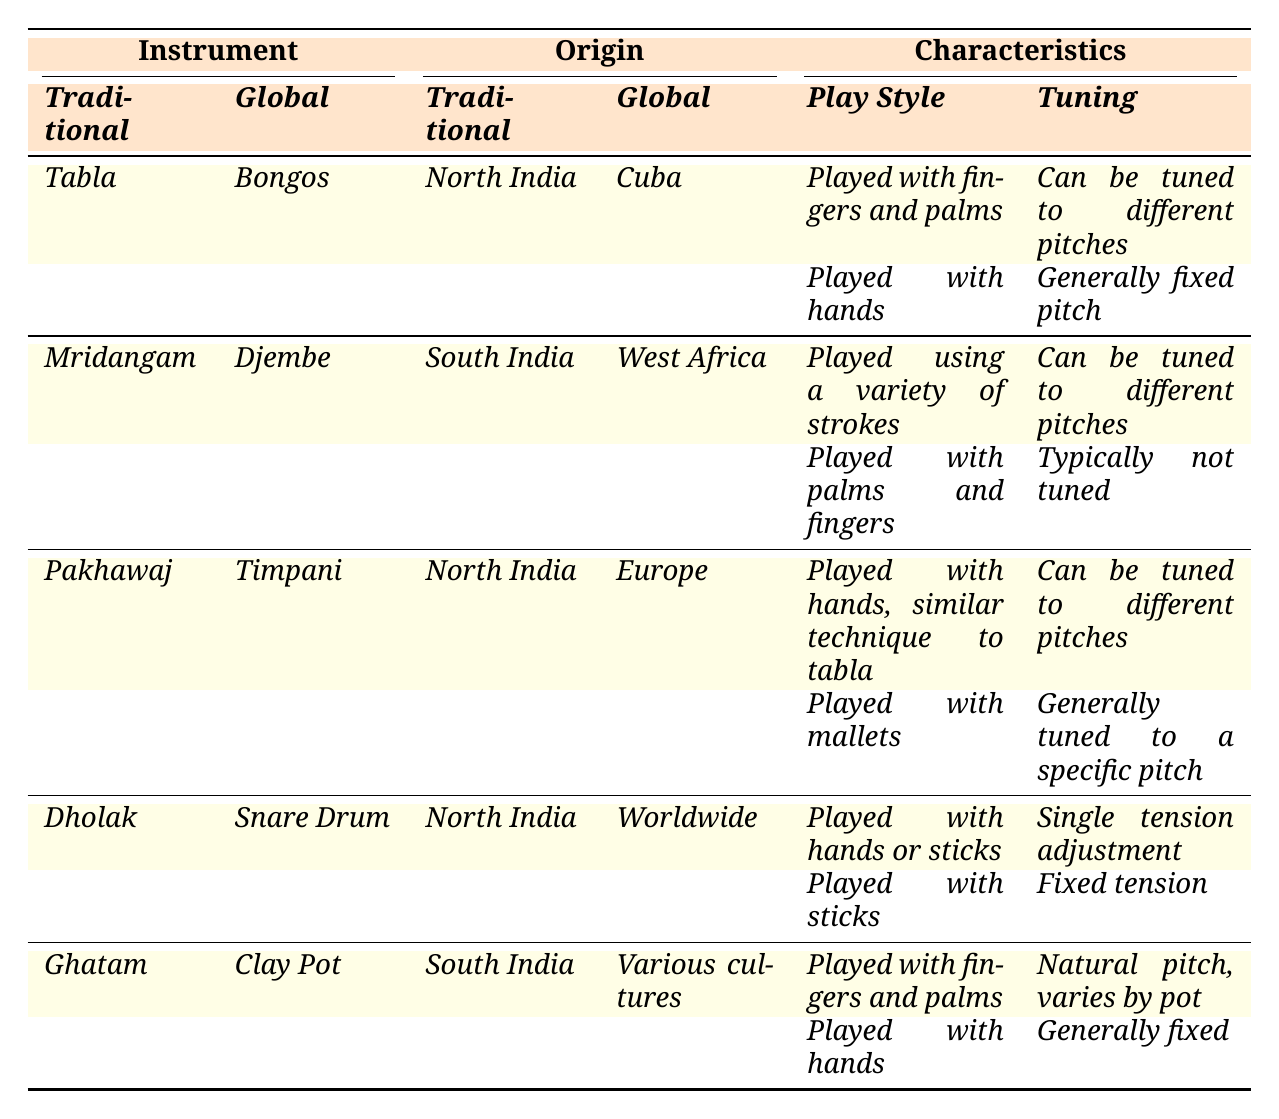What is the origin of the Mridangam? The table lists the origins of the traditional instruments. For the Mridangam, it states that its origin is South India.
Answer: South India Which traditional instrument has a global counterpart called Djembe? Referring to the table, the Djembe is listed as the global counterpart of the Mridangam.
Answer: Mridangam What tuning characteristic does the Pakhawaj and Timpani share? The table shows that both the Pakhawaj and Timpani can be tuned to different pitches since they are both listed under the 'Can be tuned to different pitches' category.
Answer: Can be tuned to different pitches Is the play style of the Tabla similar to that of Bongos? The table presents that the Tabla is played with fingers and palms while Bongos are played with hands, indicating that the play style is similar but not identical.
Answer: Yes Which traditional instrument has a play style described as played with mallets? According to the table, the instrument with a play style described as played with mallets is the Timpani, which is the global counterpart of the Pakhawaj.
Answer: Timpani Which instrument requires single tension adjustment for tuning? The table specifies that the Dholak uses a single tension adjustment for tuning.
Answer: Dholak Are the origins of the Tabla and Pakhawaj the same? The table notes that the origin of the Tabla is North India while the Pakhawaj also comes from North India, indicating they share the same origin.
Answer: Yes Which traditional instrument from South India has a natural pitch that varies by pot? The table states that the Ghatam, originating from South India, has a natural pitch that varies by pot.
Answer: Ghatam What is the primary play style difference between the Mridangam and Djembe? While both instruments are played using a variety of strokes, the Mridangam has a distinct style played using a variety of strokes and the Djembe is played with palms and fingers. This makes their play styles fundamentally different.
Answer: Different Which traditional instrument has a global counterpart that is a fixed tension drum? The table indicates that the Dholak has a global counterpart, the Snare Drum, which is categorized as having a fixed tension.
Answer: Dholak 